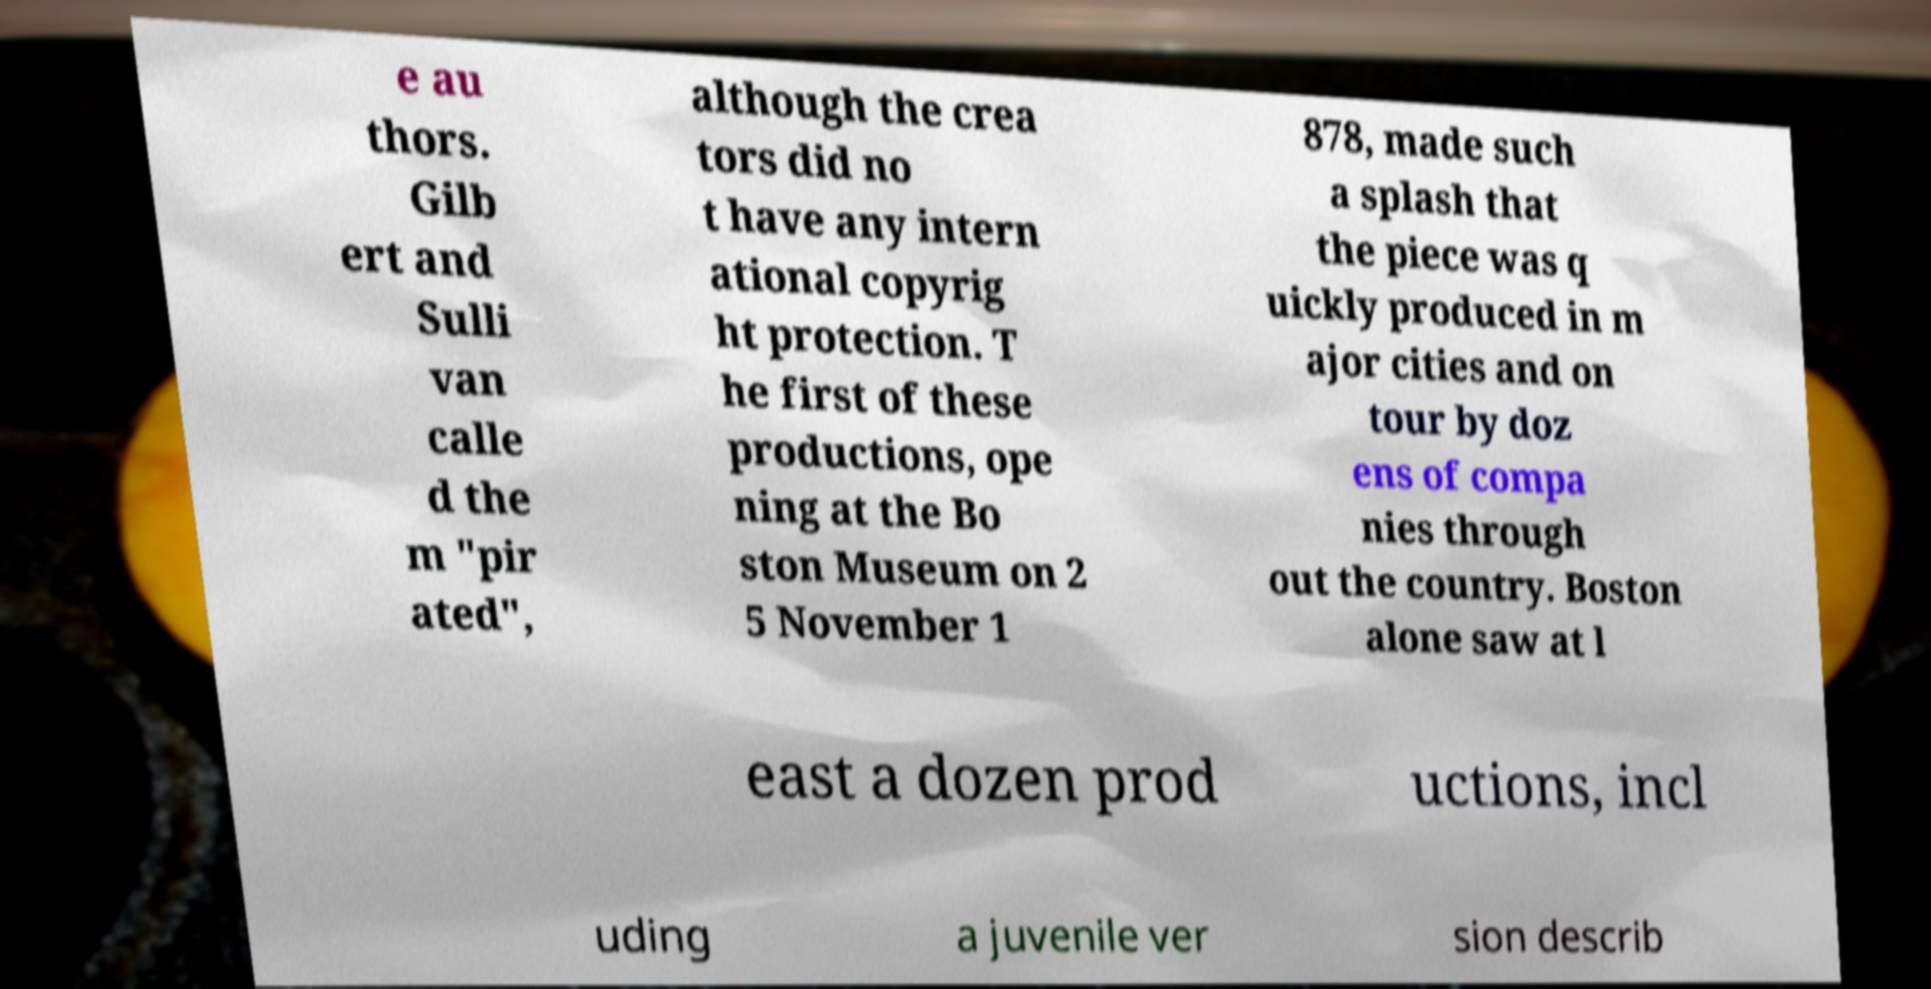Could you extract and type out the text from this image? e au thors. Gilb ert and Sulli van calle d the m "pir ated", although the crea tors did no t have any intern ational copyrig ht protection. T he first of these productions, ope ning at the Bo ston Museum on 2 5 November 1 878, made such a splash that the piece was q uickly produced in m ajor cities and on tour by doz ens of compa nies through out the country. Boston alone saw at l east a dozen prod uctions, incl uding a juvenile ver sion describ 